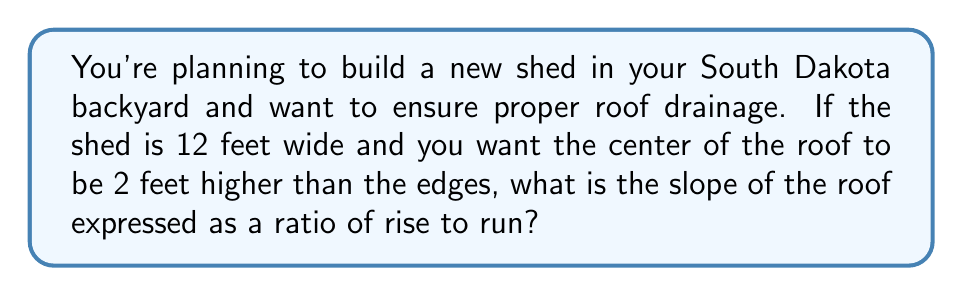Help me with this question. Let's approach this step-by-step:

1) First, we need to understand what the question is asking:
   - The shed is 12 feet wide
   - The center of the roof is 2 feet higher than the edges
   - We need to find the slope as a ratio of rise to run

2) In a roof, the run is half the width of the building:
   $$ \text{Run} = \frac{12 \text{ feet}}{2} = 6 \text{ feet} $$

3) The rise is given as 2 feet (the height difference between the center and the edge)

4) The slope of a roof is typically expressed as a ratio of rise to run:
   $$ \text{Slope} = \frac{\text{Rise}}{\text{Run}} = \frac{2 \text{ feet}}{6 \text{ feet}} $$

5) We can simplify this fraction:
   $$ \frac{2}{6} = \frac{1}{3} $$

6) Therefore, the slope can be expressed as a ratio of 1:3 (rise:run)

[asy]
unitsize(0.5cm);
draw((0,0)--(12,0)--(6,2)--cycle);
label("12 ft", (6,-0.5));
label("2 ft", (6.5,1));
label("6 ft", (3,-0.5));
draw((6,0)--(6,2),dashed);
[/asy]
Answer: 1:3 